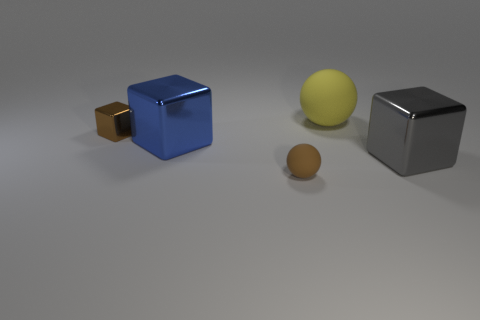What can you infer about the surface on which the objects are placed? The surface appears to be smooth and slightly reflective, with a matte finish that softly mirrors the shapes of the objects. The even tone and lack of visible texture suggest it might be made of a refined material like polished concrete or matte plastic. 